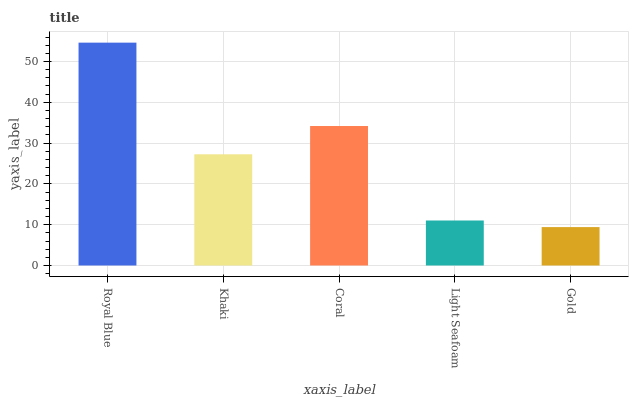Is Gold the minimum?
Answer yes or no. Yes. Is Royal Blue the maximum?
Answer yes or no. Yes. Is Khaki the minimum?
Answer yes or no. No. Is Khaki the maximum?
Answer yes or no. No. Is Royal Blue greater than Khaki?
Answer yes or no. Yes. Is Khaki less than Royal Blue?
Answer yes or no. Yes. Is Khaki greater than Royal Blue?
Answer yes or no. No. Is Royal Blue less than Khaki?
Answer yes or no. No. Is Khaki the high median?
Answer yes or no. Yes. Is Khaki the low median?
Answer yes or no. Yes. Is Light Seafoam the high median?
Answer yes or no. No. Is Coral the low median?
Answer yes or no. No. 